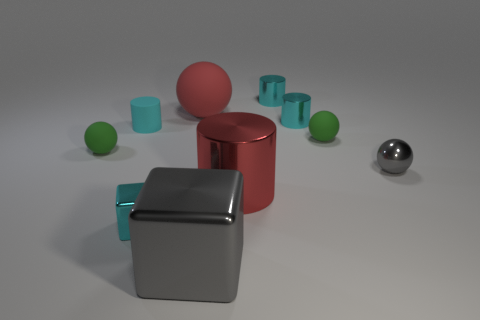What is the shape of the cyan metal object left of the large metallic cylinder?
Your answer should be compact. Cube. There is a green rubber ball behind the small sphere to the left of the cyan cube; what is its size?
Offer a very short reply. Small. Is the shape of the gray object that is right of the large red cylinder the same as the object that is behind the large ball?
Provide a succinct answer. No. What shape is the large object in front of the big red object that is in front of the red matte thing?
Give a very brief answer. Cube. What is the size of the ball that is both in front of the big matte ball and left of the big gray block?
Offer a terse response. Small. There is a big gray shiny thing; is it the same shape as the red thing on the right side of the large gray thing?
Provide a short and direct response. No. The cyan matte thing that is the same shape as the red metallic object is what size?
Your answer should be very brief. Small. There is a small shiny sphere; is it the same color as the tiny object in front of the small gray shiny ball?
Your answer should be very brief. No. How many other things are there of the same size as the cyan shiny cube?
Provide a succinct answer. 6. There is a tiny green thing that is right of the block that is on the left side of the shiny cube in front of the tiny metallic block; what shape is it?
Provide a short and direct response. Sphere. 